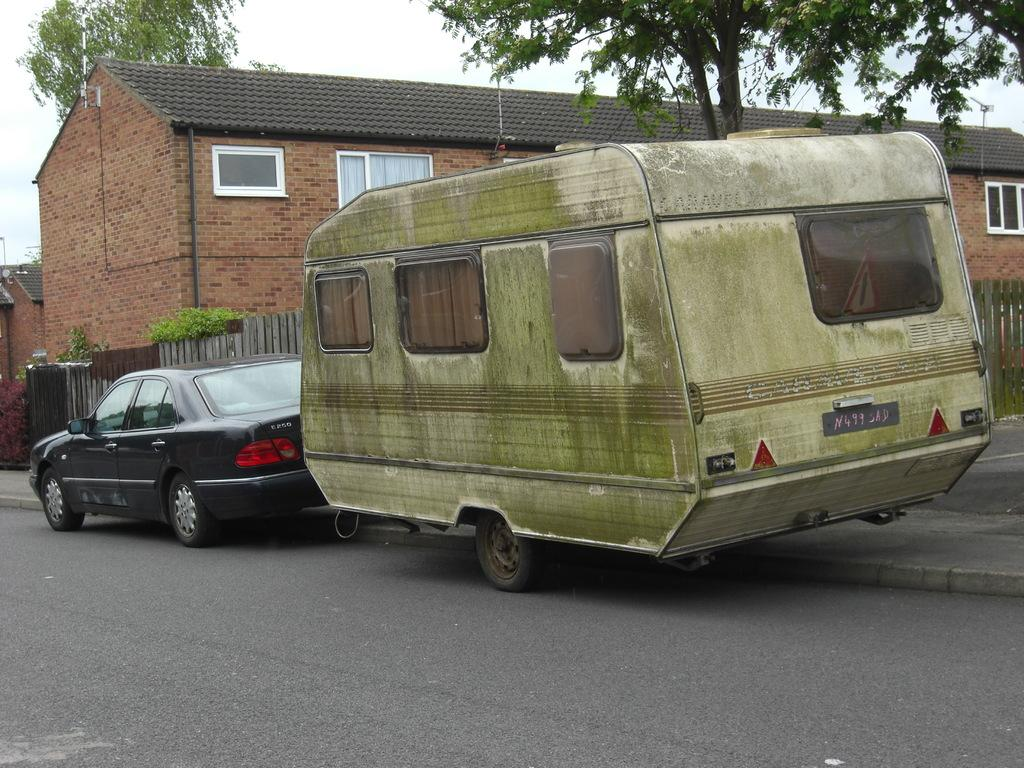What can be seen on the road in the image? There are vehicles on the road in the image. What type of structure is present in the image? There is a house in the image. What feature of the house is mentioned in the facts? The house has windows. What type of barrier is present in the image? There is a fence in the image. What type of natural elements are present in the image? Plants and trees are present in the image. What part of the natural environment is visible in the image? The sky is visible in the image. What type of jam is being spread on the fence in the image? There is no jam present in the image; it features vehicles on the road, a house with windows, a fence, plants, trees, and the sky. What is the mouth of the tree doing in the image? There is no mouth present in the image, as trees do not have mouths. 